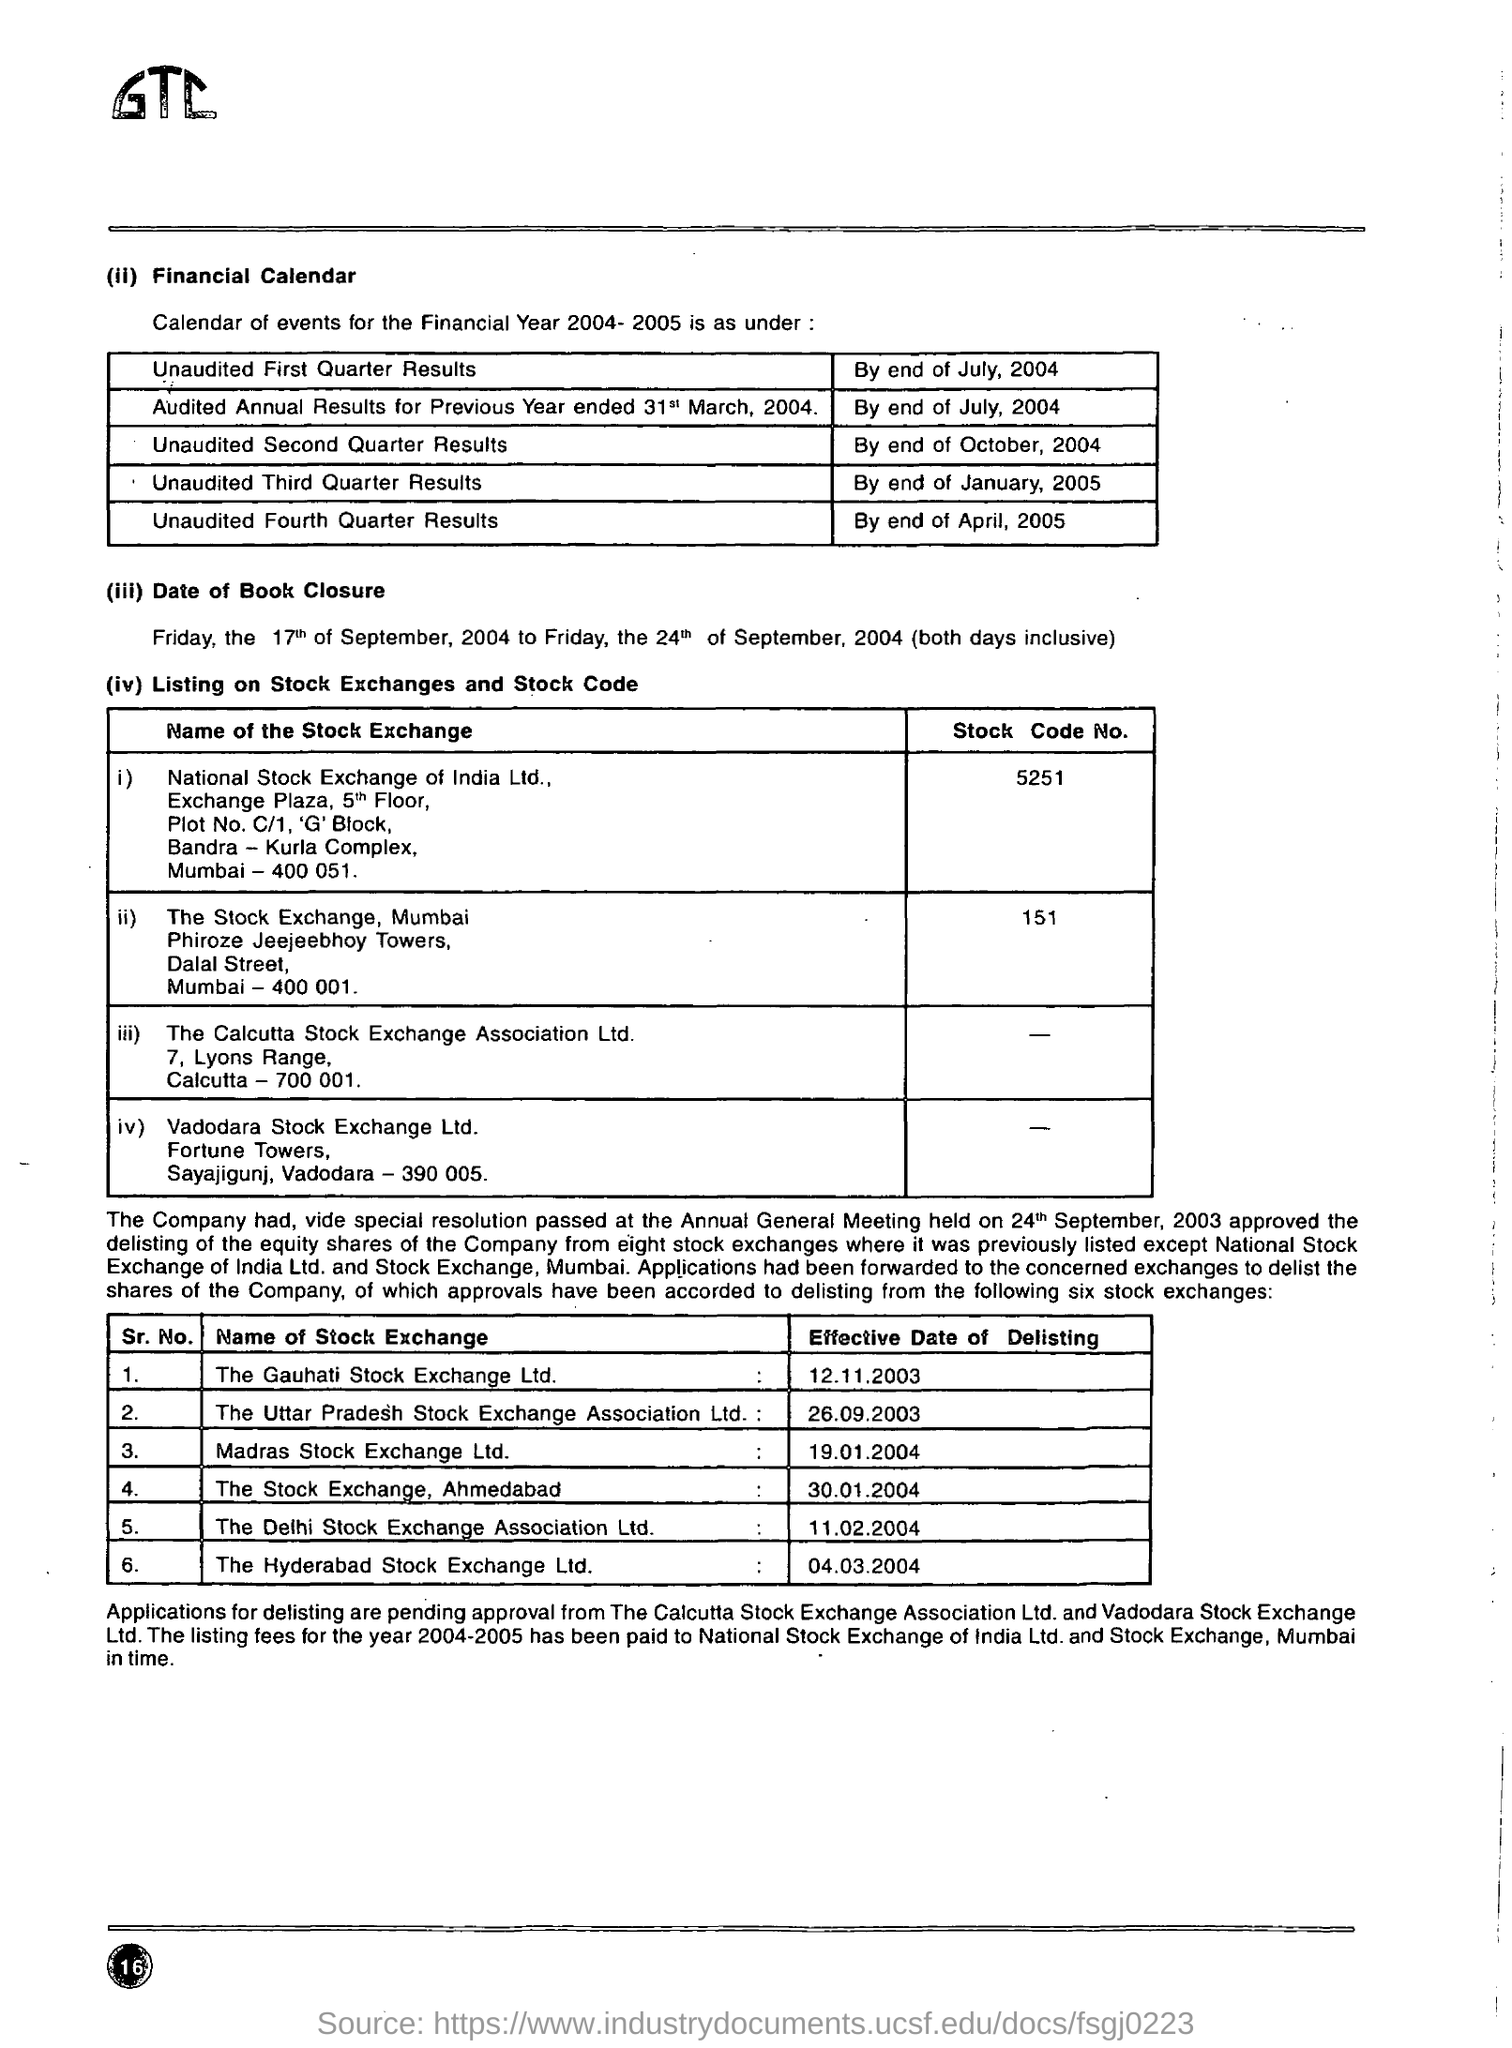What is the national stock exchange of india ltd stock code no ?
Provide a short and direct response. 5251. What is the stock code no of the stock exchange , mumbai
Offer a very short reply. 151. What is the effective date of delisting for the  gahuti stock exchange ltd
Your response must be concise. 12.11.2003. What is the effective date of delisting for the hyderabad stock exchange ltd
Your answer should be very brief. 04.03.2004. What is the effective date of delisting for the stock exchange ahmedabad
Provide a succinct answer. 30.01.2004. By when the unaudited first quarter results are declared ?
Make the answer very short. By end of july ,2004. By when the unaudited second quarter results are declared ?
Provide a short and direct response. By the end of october ,2004. By when the unaudited third  quarter results are declared ?
Give a very brief answer. By end of january, 2005. By when the unaudited fourth  quarter results are declared ?
Provide a succinct answer. By end of April, 2005. 